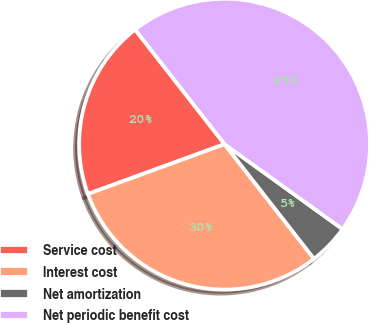Convert chart. <chart><loc_0><loc_0><loc_500><loc_500><pie_chart><fcel>Service cost<fcel>Interest cost<fcel>Net amortization<fcel>Net periodic benefit cost<nl><fcel>20.02%<fcel>29.98%<fcel>4.52%<fcel>45.48%<nl></chart> 